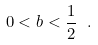<formula> <loc_0><loc_0><loc_500><loc_500>0 < b < \frac { 1 } { 2 } \ .</formula> 